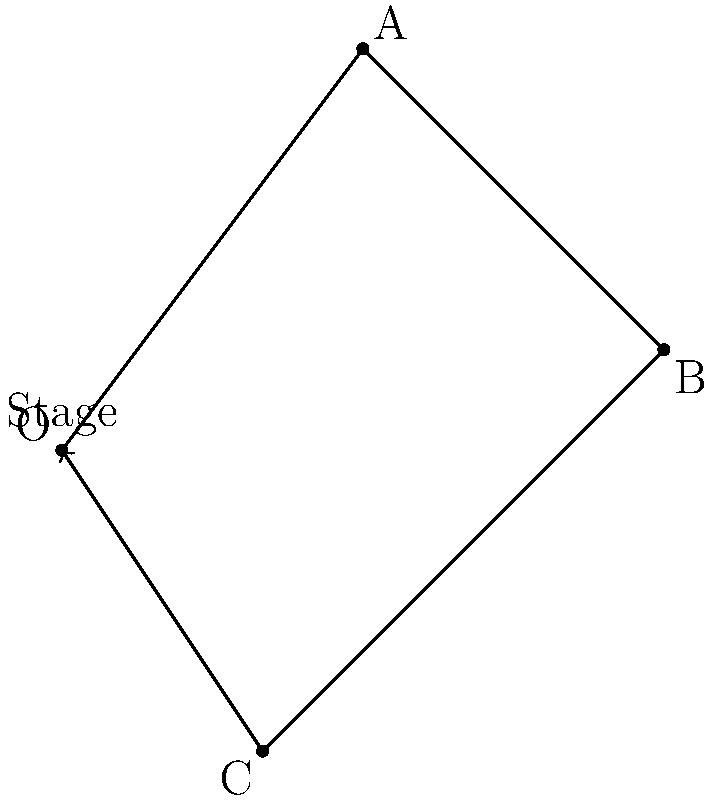In a multi-genre performance, you need to optimize the stage positioning for four dancers. The stage is represented as a 2D plane with the origin (0,0) at the center. Dancer A is at position (3,4), B at (6,1), and C at (2,-3). To create a balanced formation, you want to find the position of dancer D such that the sum of all position vectors is zero. What are the coordinates of dancer D's position? Let's approach this step-by-step:

1) First, let's recall that for the sum of vectors to be zero, we need:
   $$\vec{OA} + \vec{OB} + \vec{OC} + \vec{OD} = \vec{0}$$

2) We know the positions of A, B, and C. Let's call D's position (x,y). We can write:
   $$(3,4) + (6,1) + (2,-3) + (x,y) = (0,0)$$

3) This vector equation can be split into two scalar equations:
   $$3 + 6 + 2 + x = 0$$
   $$4 + 1 - 3 + y = 0$$

4) From the first equation:
   $$11 + x = 0$$
   $$x = -11$$

5) From the second equation:
   $$2 + y = 0$$
   $$y = -2$$

6) Therefore, the position of dancer D should be (-11, -2).

7) We can verify:
   $$(3,4) + (6,1) + (2,-3) + (-11,-2) = (0,0)$$

This positioning will create a balanced formation where the dancers' positions sum to the center of the stage.
Answer: (-11, -2) 